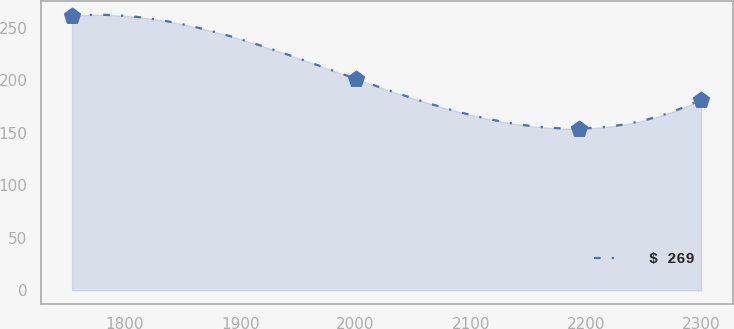Convert chart. <chart><loc_0><loc_0><loc_500><loc_500><line_chart><ecel><fcel>$ 269<nl><fcel>1754.04<fcel>261.58<nl><fcel>2000.61<fcel>201.44<nl><fcel>2193.89<fcel>154.2<nl><fcel>2299.94<fcel>181.85<nl></chart> 